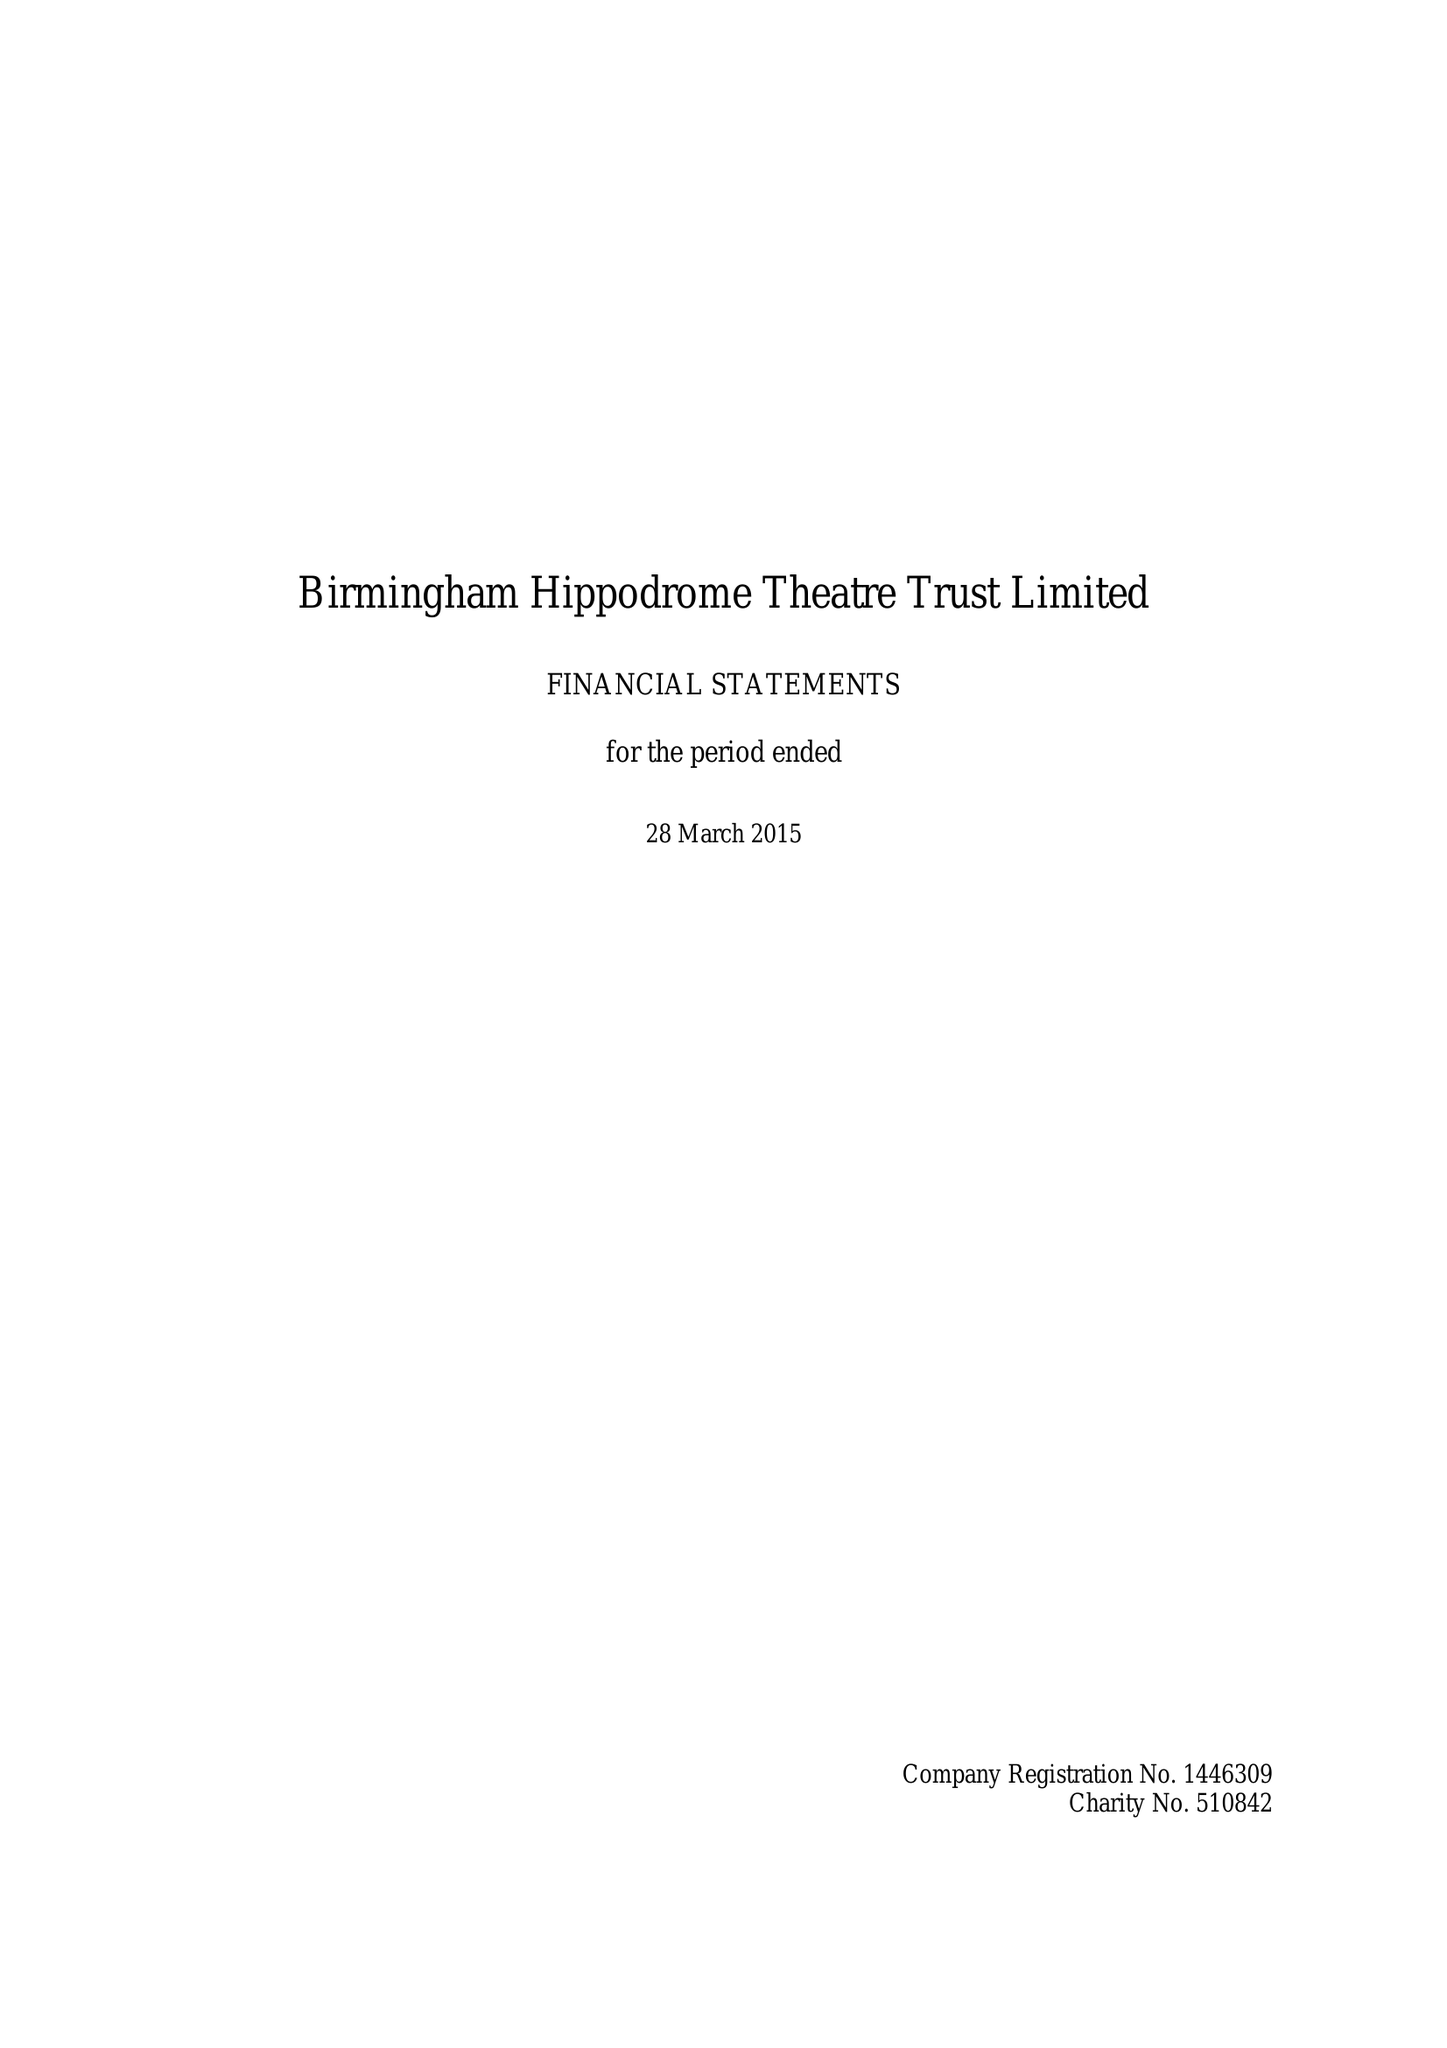What is the value for the spending_annually_in_british_pounds?
Answer the question using a single word or phrase. 24714000.00 